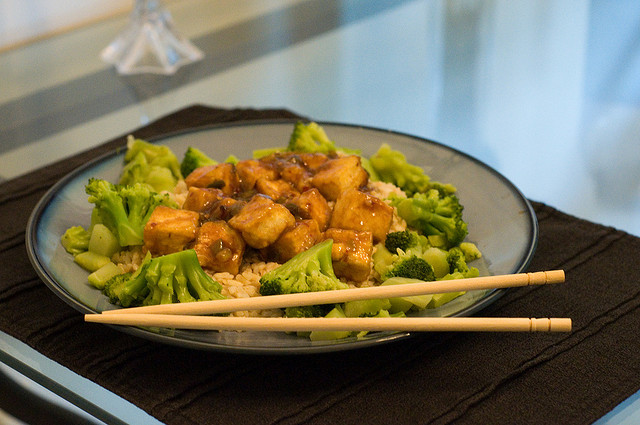<image>What is the topping on the dish? It is unclear what the topping on the dish is. It could be chicken, sauce, pork, broccoli, or sesame seeds. What is the topping on the dish? I am not sure what the topping is on the dish. It can be chicken, sauce, pork, broccoli, or sesame seeds. 